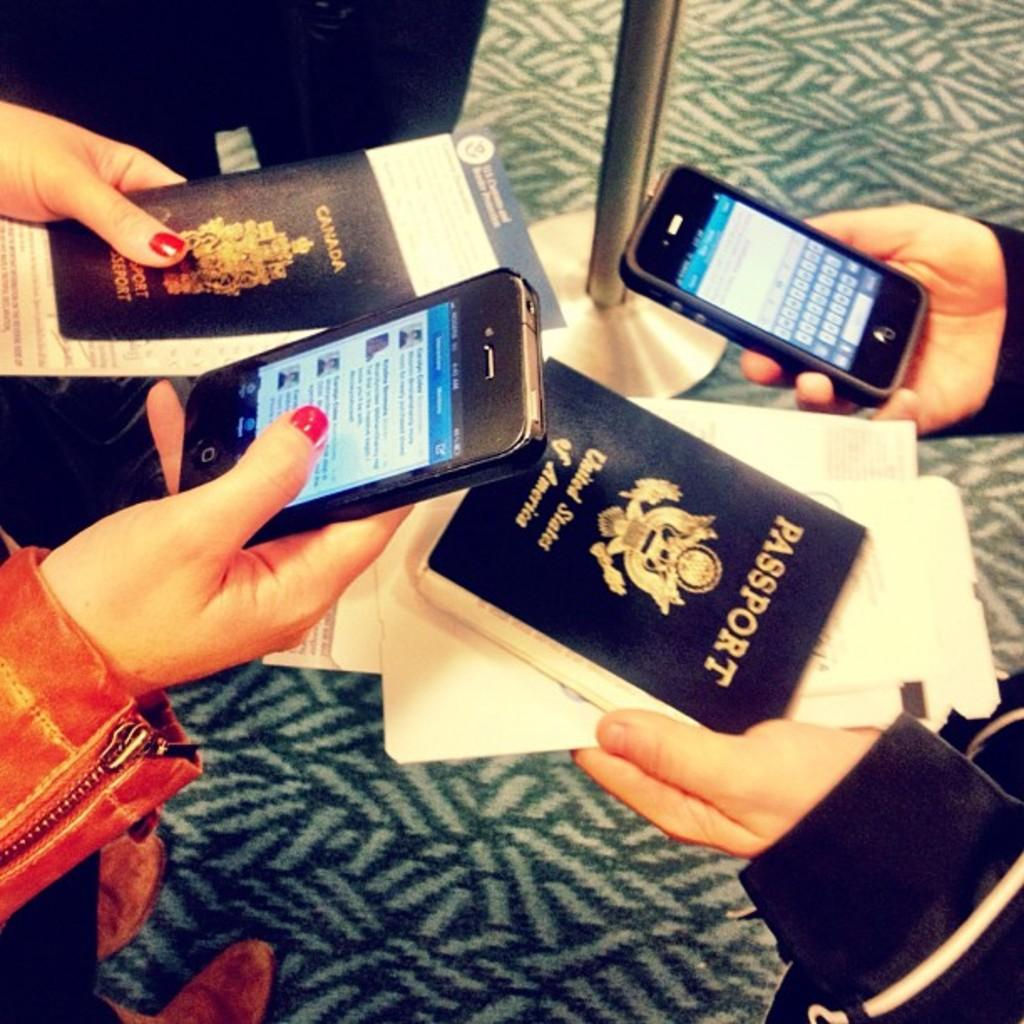<image>
Create a compact narrative representing the image presented. Two people hold their cellphones and their passports. 